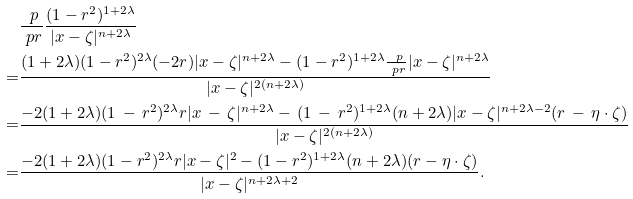Convert formula to latex. <formula><loc_0><loc_0><loc_500><loc_500>& \frac { \ p } { \ p r } \frac { ( 1 - r ^ { 2 } ) ^ { 1 + 2 \lambda } } { | x - \zeta | ^ { n + 2 \lambda } } \\ = & \frac { ( 1 + 2 \lambda ) ( 1 - r ^ { 2 } ) ^ { 2 \lambda } ( - 2 r ) | x - \zeta | ^ { n + 2 \lambda } - ( 1 - r ^ { 2 } ) ^ { 1 + 2 \lambda } \frac { \ p } { \ p r } | x - \zeta | ^ { n + 2 \lambda } } { | x - \zeta | ^ { 2 ( n + 2 \lambda ) } } \\ = & \frac { - 2 ( 1 + 2 \lambda ) ( 1 \, - \, r ^ { 2 } ) ^ { 2 \lambda } r | x \, - \, \zeta | ^ { n + 2 \lambda } - \, ( 1 \, - \, r ^ { 2 } ) ^ { 1 + 2 \lambda } ( n + 2 \lambda ) | x - \zeta | ^ { n + 2 \lambda - 2 } ( r \, - \, \eta \cdot \zeta ) } { | x - \zeta | ^ { 2 ( n + 2 \lambda ) } } \\ = & \frac { - 2 ( 1 + 2 \lambda ) ( 1 - r ^ { 2 } ) ^ { 2 \lambda } r | x - \zeta | ^ { 2 } - ( 1 - r ^ { 2 } ) ^ { 1 + 2 \lambda } ( n + 2 \lambda ) ( r - \eta \cdot \zeta ) } { | x - \zeta | ^ { n + 2 \lambda + 2 } } .</formula> 